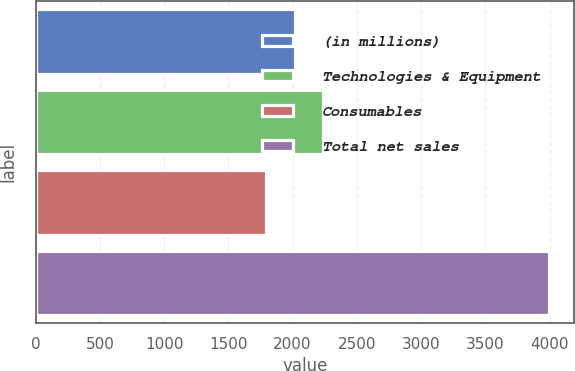<chart> <loc_0><loc_0><loc_500><loc_500><bar_chart><fcel>(in millions)<fcel>Technologies & Equipment<fcel>Consumables<fcel>Total net sales<nl><fcel>2017<fcel>2237.08<fcel>1792.6<fcel>3993.4<nl></chart> 